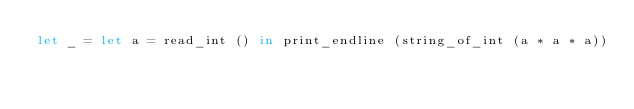Convert code to text. <code><loc_0><loc_0><loc_500><loc_500><_OCaml_>let _ = let a = read_int () in print_endline (string_of_int (a * a * a))
</code> 